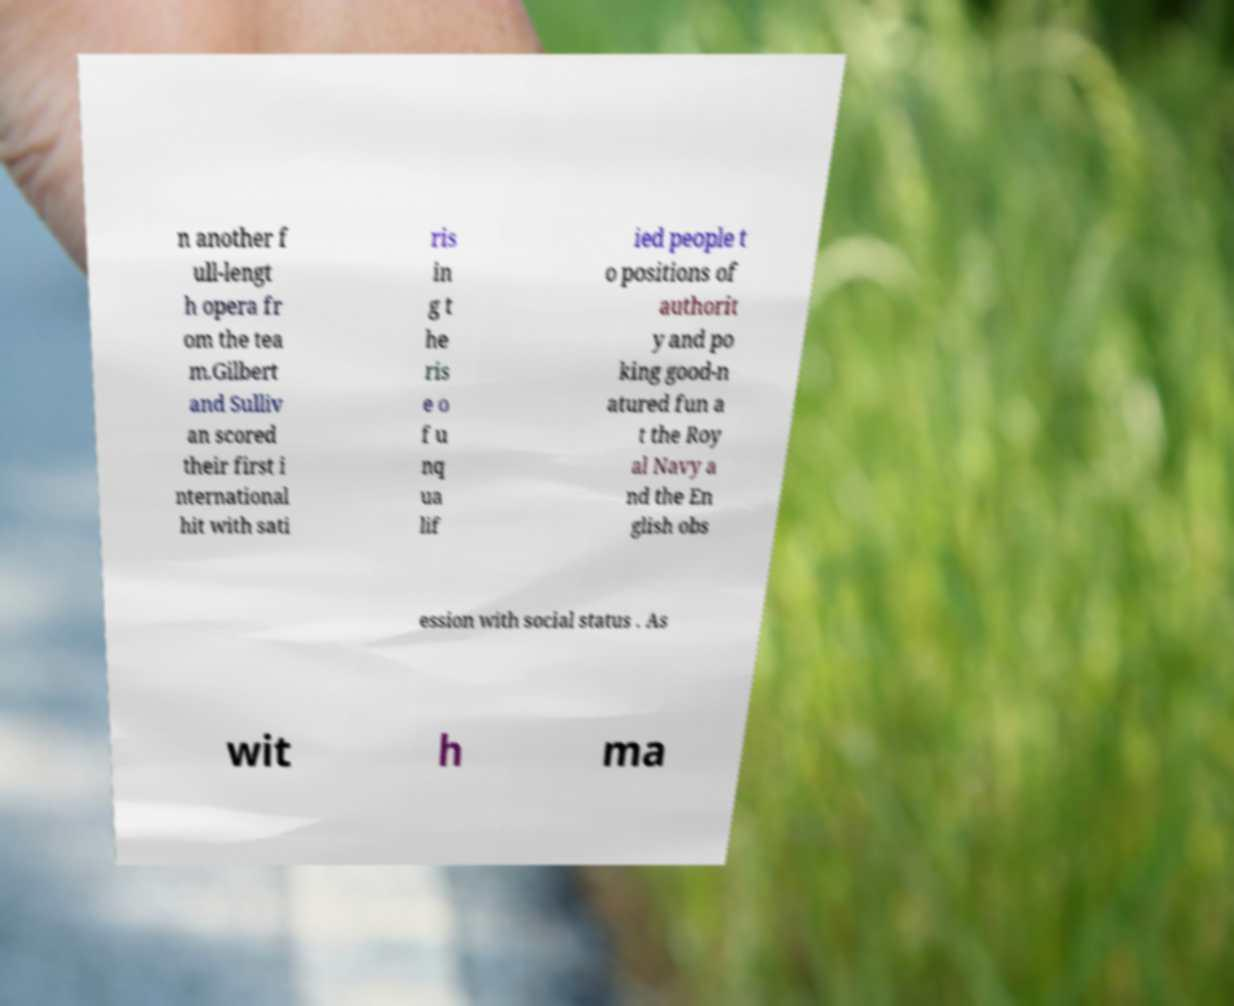Could you assist in decoding the text presented in this image and type it out clearly? n another f ull-lengt h opera fr om the tea m.Gilbert and Sulliv an scored their first i nternational hit with sati ris in g t he ris e o f u nq ua lif ied people t o positions of authorit y and po king good-n atured fun a t the Roy al Navy a nd the En glish obs ession with social status . As wit h ma 